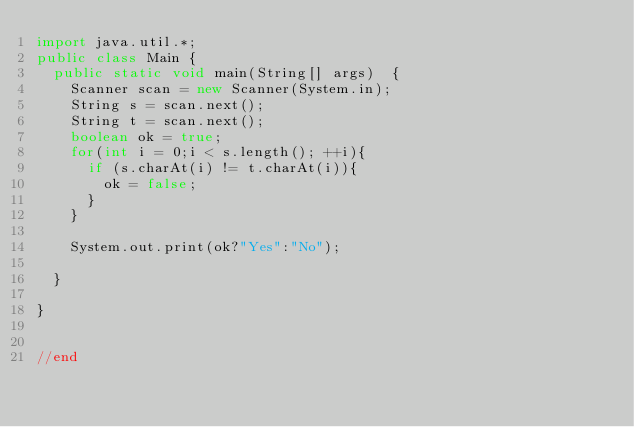<code> <loc_0><loc_0><loc_500><loc_500><_Java_>import java.util.*;
public class Main {
	public static void main(String[] args)  {
		Scanner scan = new Scanner(System.in);
		String s = scan.next();
		String t = scan.next();
		boolean ok = true;
		for(int i = 0;i < s.length(); ++i){
			if (s.charAt(i) != t.charAt(i)){
				ok = false;
			}
		}

		System.out.print(ok?"Yes":"No");

	}

}


//end</code> 